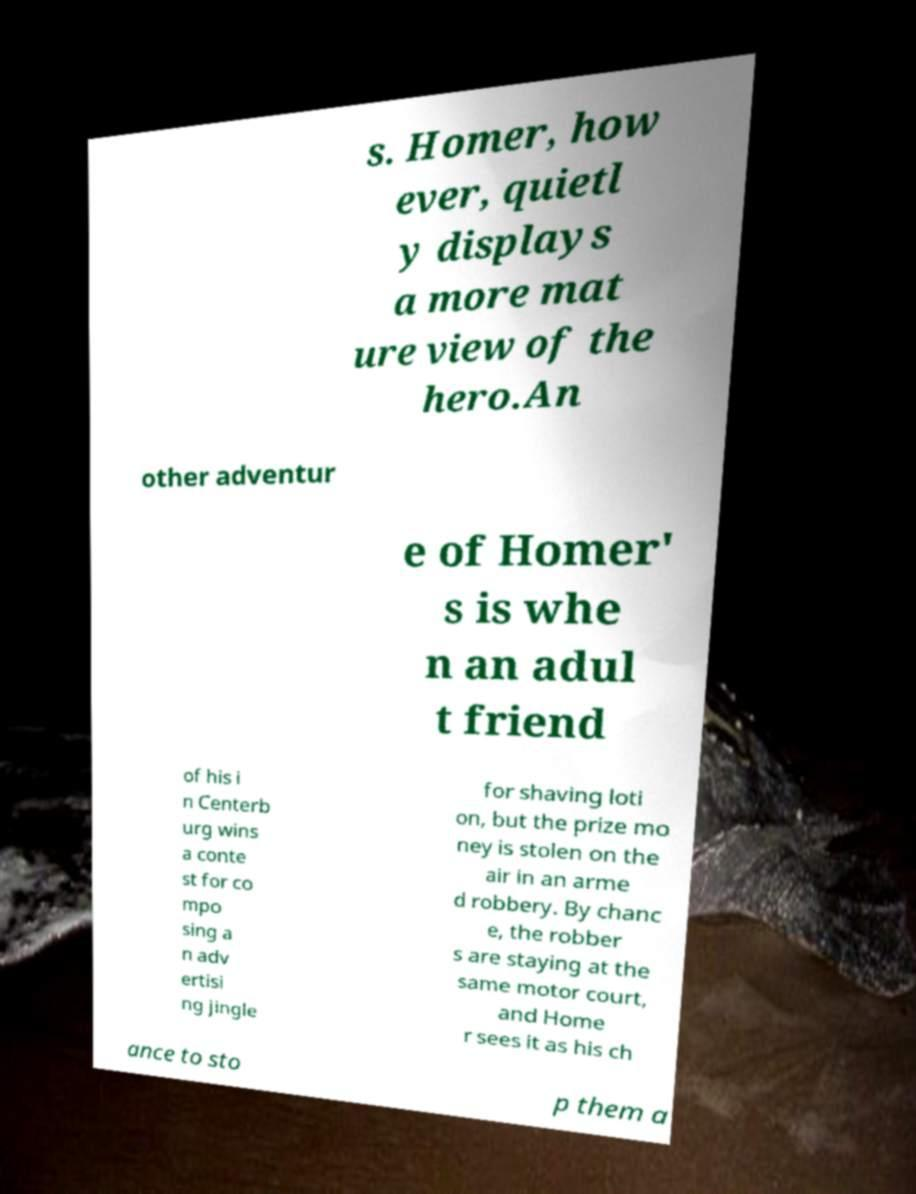Please identify and transcribe the text found in this image. s. Homer, how ever, quietl y displays a more mat ure view of the hero.An other adventur e of Homer' s is whe n an adul t friend of his i n Centerb urg wins a conte st for co mpo sing a n adv ertisi ng jingle for shaving loti on, but the prize mo ney is stolen on the air in an arme d robbery. By chanc e, the robber s are staying at the same motor court, and Home r sees it as his ch ance to sto p them a 